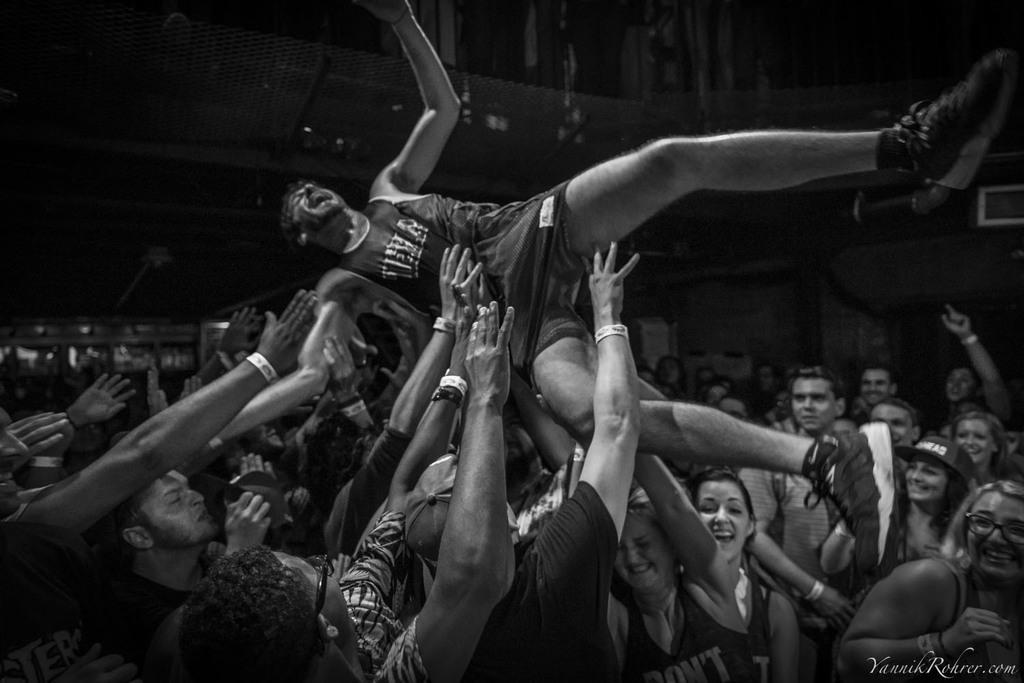Can you describe this image briefly? In this picture I can see many persons who are throwing to this man. in the back I can see the stadium. On the right I can see the basketball court. In the bottom right corner there is a watermark. 